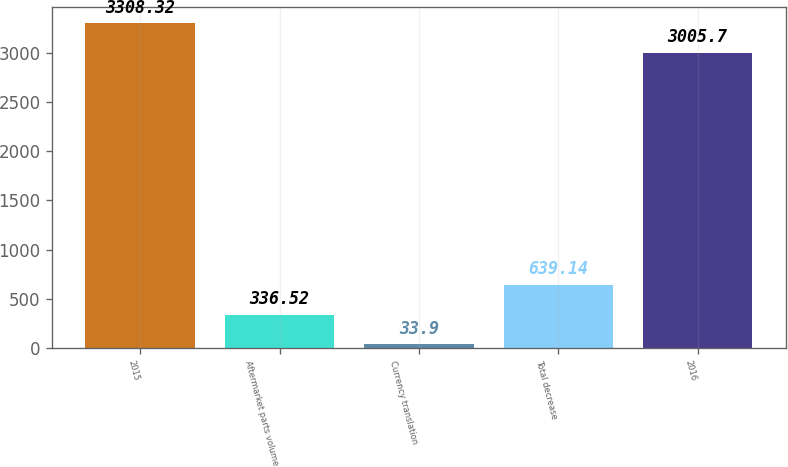Convert chart. <chart><loc_0><loc_0><loc_500><loc_500><bar_chart><fcel>2015<fcel>Aftermarket parts volume<fcel>Currency translation<fcel>Total decrease<fcel>2016<nl><fcel>3308.32<fcel>336.52<fcel>33.9<fcel>639.14<fcel>3005.7<nl></chart> 